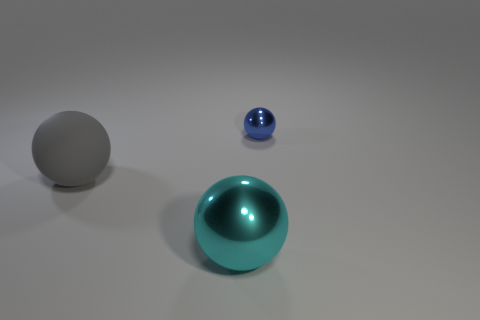Is there any other thing that has the same size as the blue ball?
Ensure brevity in your answer.  No. Are there more small blue spheres on the right side of the small blue metal object than green matte cylinders?
Offer a very short reply. No. Are there fewer gray objects in front of the big rubber object than tiny yellow matte cylinders?
Provide a succinct answer. No. What number of big shiny things are the same color as the matte sphere?
Provide a short and direct response. 0. What is the material of the ball that is in front of the small object and right of the rubber ball?
Offer a terse response. Metal. There is a metallic object that is in front of the tiny blue shiny ball; is its color the same as the sphere on the left side of the big metallic thing?
Give a very brief answer. No. What number of gray objects are tiny balls or rubber balls?
Make the answer very short. 1. Are there fewer large gray objects that are right of the large cyan sphere than small blue shiny balls that are in front of the blue metallic ball?
Provide a succinct answer. No. Is there a blue metallic ball that has the same size as the gray rubber object?
Keep it short and to the point. No. Do the metal object in front of the gray rubber object and the tiny blue object have the same size?
Your response must be concise. No. 